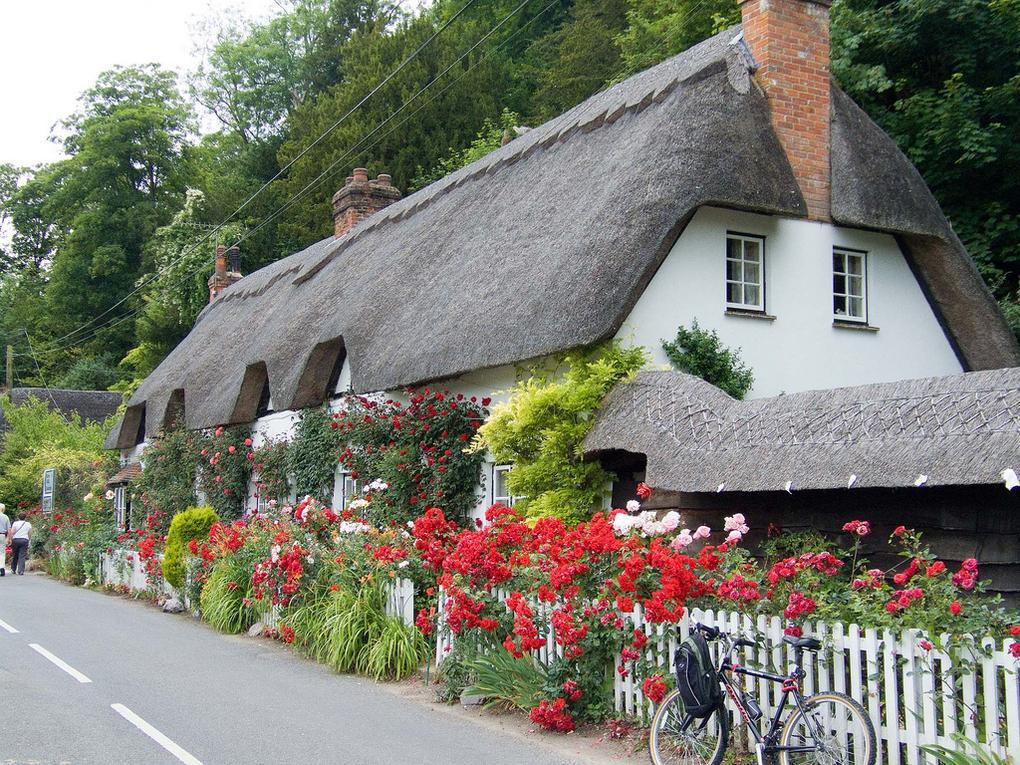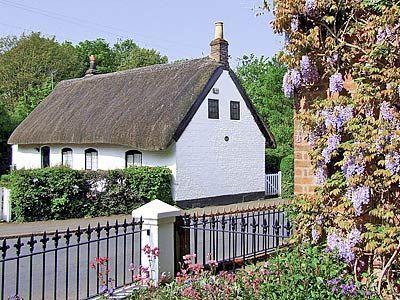The first image is the image on the left, the second image is the image on the right. For the images displayed, is the sentence "The left image shows a white building with at least three notches around windows at the bottom of its gray roof, and a scalloped border along the top of the roof." factually correct? Answer yes or no. Yes. The first image is the image on the left, the second image is the image on the right. Considering the images on both sides, is "There is a total of five chimneys." valid? Answer yes or no. Yes. 